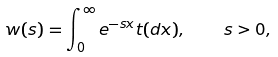<formula> <loc_0><loc_0><loc_500><loc_500>w ( s ) = \int _ { 0 } ^ { \infty } e ^ { - s x } t ( d x ) , \quad s > 0 ,</formula> 